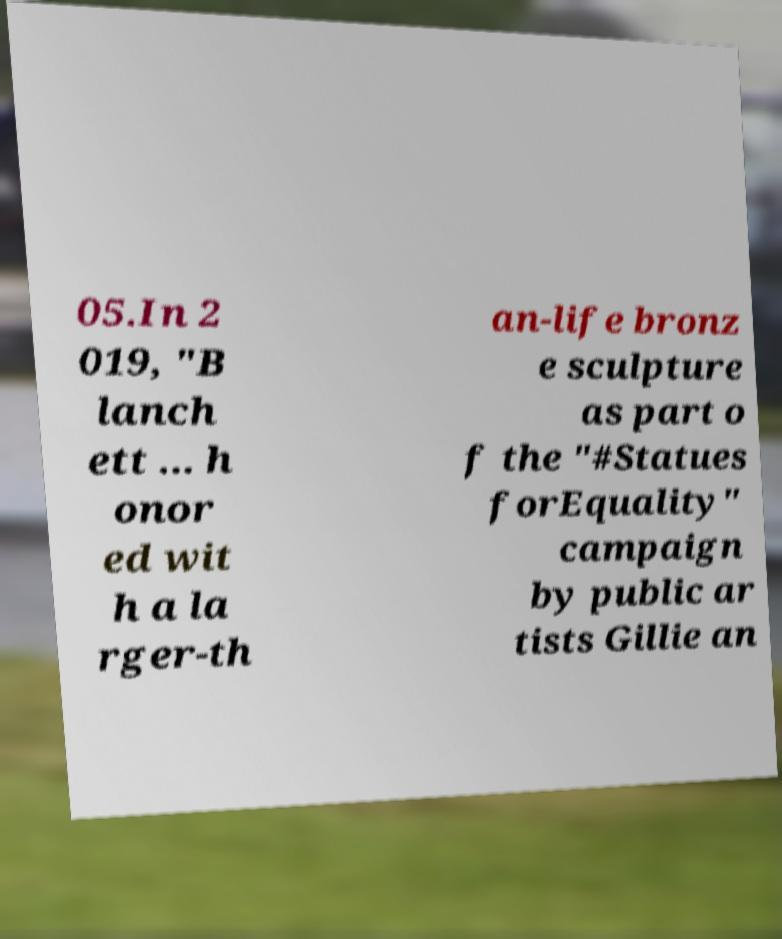Could you extract and type out the text from this image? 05.In 2 019, "B lanch ett ... h onor ed wit h a la rger-th an-life bronz e sculpture as part o f the "#Statues forEquality" campaign by public ar tists Gillie an 